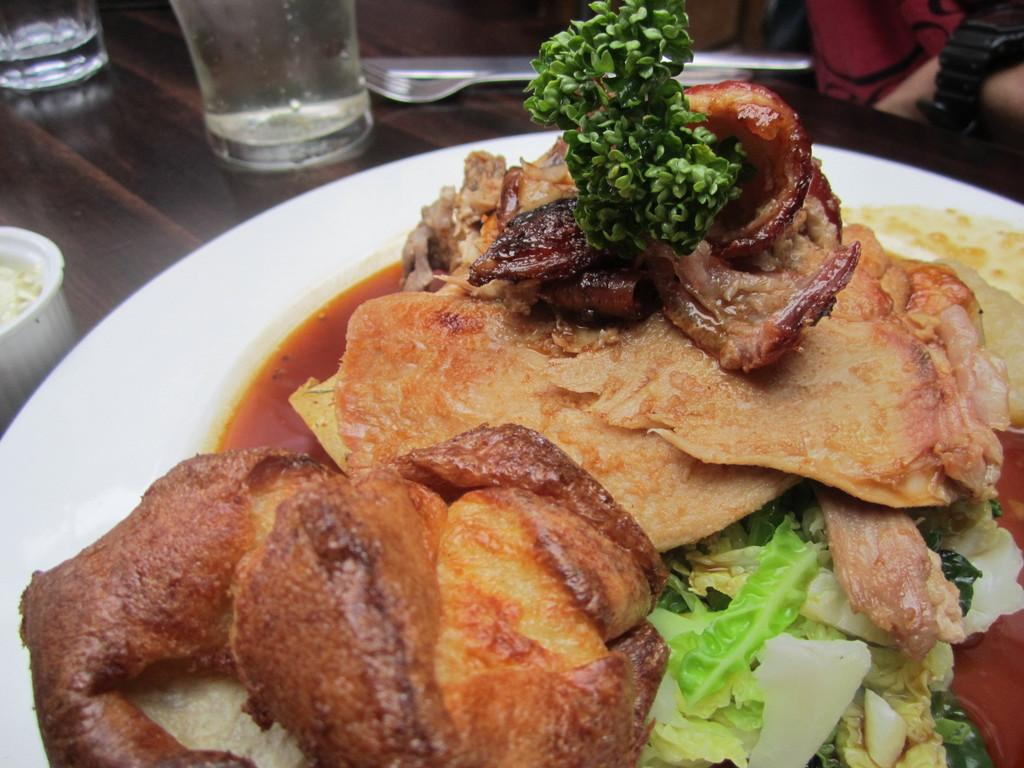What type of objects can be seen in the image? There are food items in the image. What colors are the food items? The food items are in brown and green colors. How are the food items arranged? The food is in a plate. What color is the plate? The plate is white. What else can be seen in the background of the image? There are glasses in the background of the image. Where are the kittens playing in the image? There are no kittens present in the image. What type of trouble is the food causing in the image? The food is not causing any trouble in the image; it is simply arranged on a plate. 